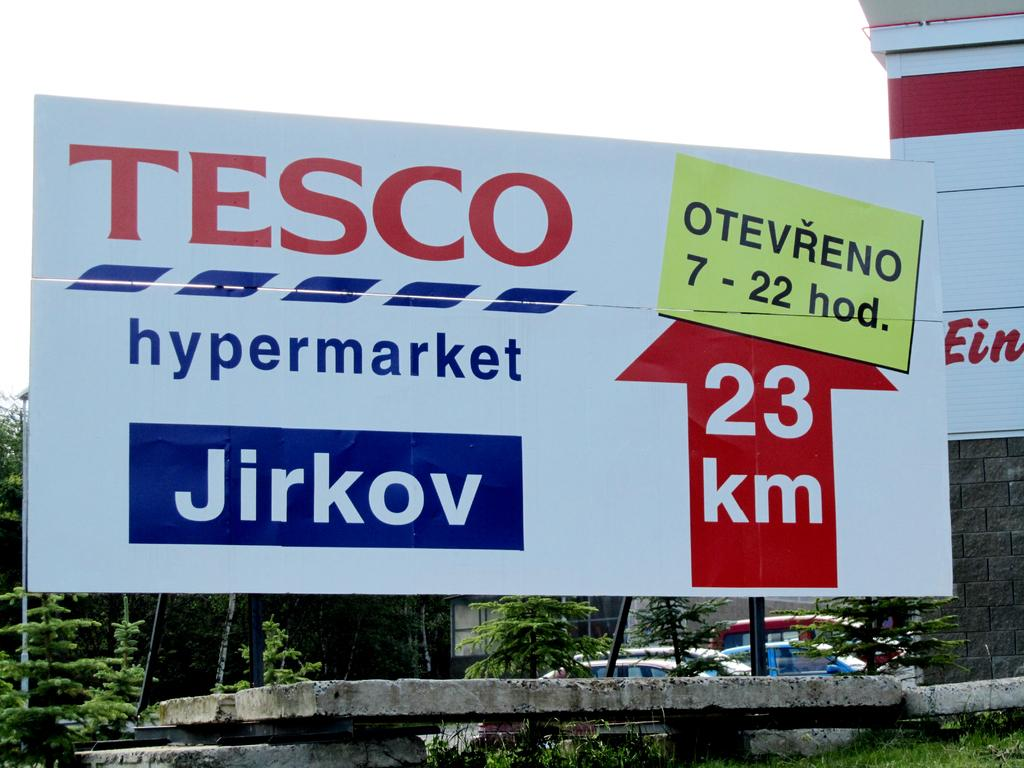<image>
Render a clear and concise summary of the photo. A Tesco billboard for their hypermarket tells us it is 23 km away. 